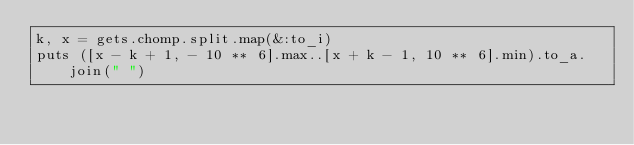Convert code to text. <code><loc_0><loc_0><loc_500><loc_500><_Ruby_>k, x = gets.chomp.split.map(&:to_i)
puts ([x - k + 1, - 10 ** 6].max..[x + k - 1, 10 ** 6].min).to_a.join(" ")</code> 